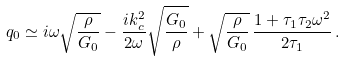<formula> <loc_0><loc_0><loc_500><loc_500>q _ { 0 } \simeq i \omega \sqrt { \frac { \rho } { G _ { 0 } } } - \frac { i k _ { c } ^ { 2 } } { 2 \omega } \sqrt { \frac { G _ { 0 } } { \rho } } + \sqrt { \frac { \rho } { G _ { 0 } } } \, \frac { 1 + \tau _ { 1 } \tau _ { 2 } \omega ^ { 2 } } { 2 \tau _ { 1 } } \, .</formula> 